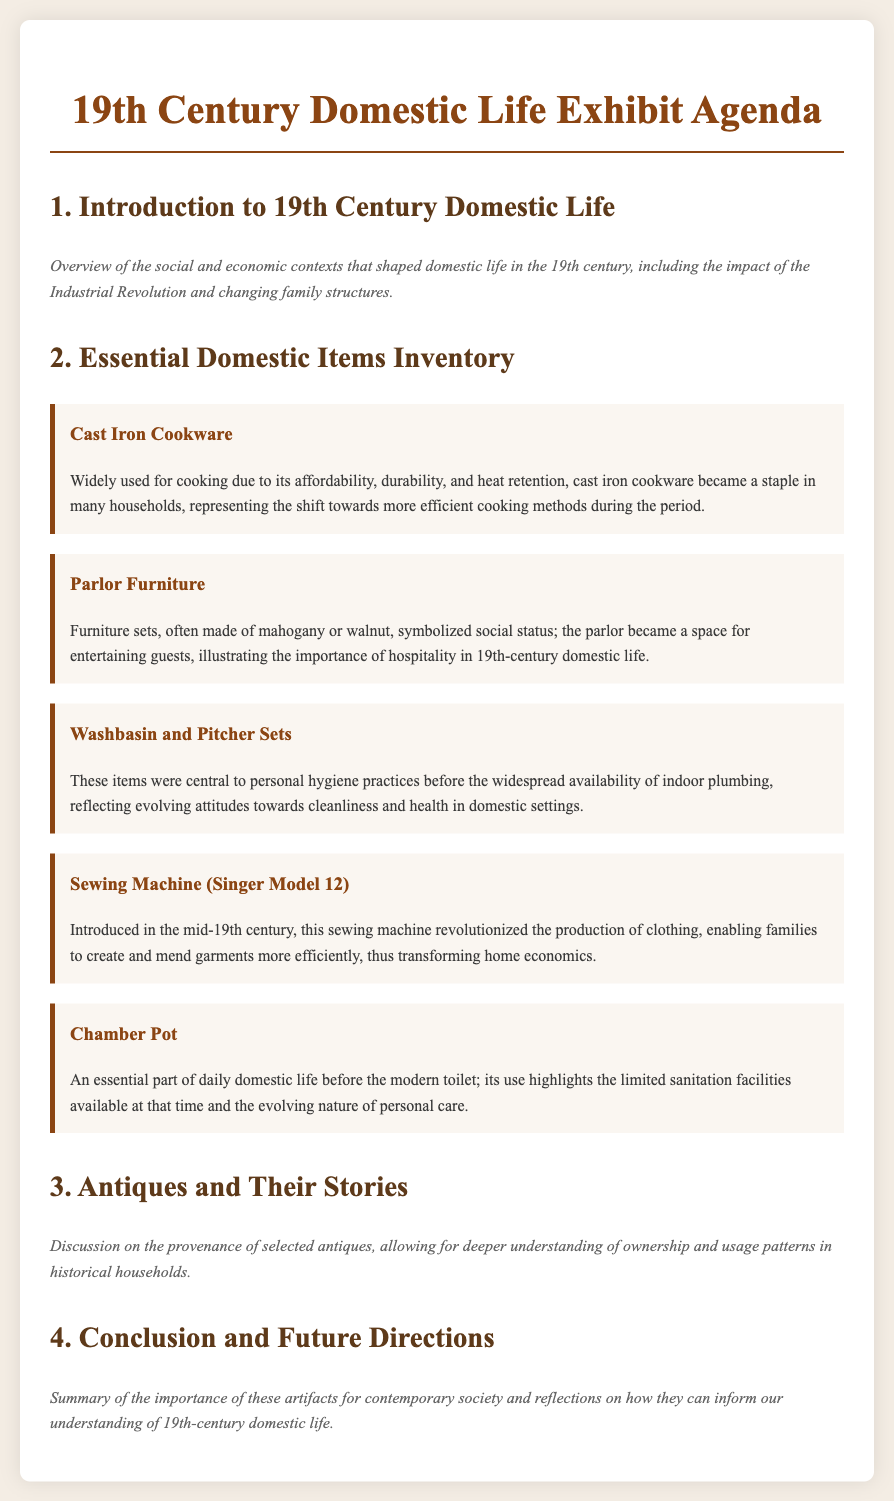What is the title of the exhibit? The title of the exhibit is stated prominently at the top of the document.
Answer: 19th Century Domestic Life Exhibit Agenda What item symbolized social status in 19th-century homes? The document mentions that parlor furniture sets were a representation of social status.
Answer: Parlor Furniture What kitchen item was a staple due to its durability? The document highlights cast iron cookware as a widely used kitchen item for its affordability and durability.
Answer: Cast Iron Cookware Which sewing machine model is mentioned? The document specifies the Singer Model 12 as a revolutionary sewing machine introduced in the mid-19th century.
Answer: Singer Model 12 What hygiene practice was emphasized with washbasin and pitcher sets? These items reflect the evolving attitudes towards cleanliness and health in domestic settings.
Answer: Personal hygiene How many main sections are there in the agenda? The document outlines four main sections in the agenda.
Answer: Four What was the main function of the chamber pot? The document explains the chamber pot as an essential part of daily domestic life before modern toilets.
Answer: Personal care What major societal change influenced domestic life during the 19th century? The document indicates the impact of the Industrial Revolution as a significant factor in shaping domestic life.
Answer: Industrial Revolution What does the conclusion section focus on? The conclusion section summarizes the importance of artifacts for contemporary society and how they inform our understanding of the past.
Answer: Importance of artifacts 